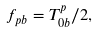<formula> <loc_0><loc_0><loc_500><loc_500>f _ { p b } = T ^ { p } _ { 0 b } / 2 ,</formula> 